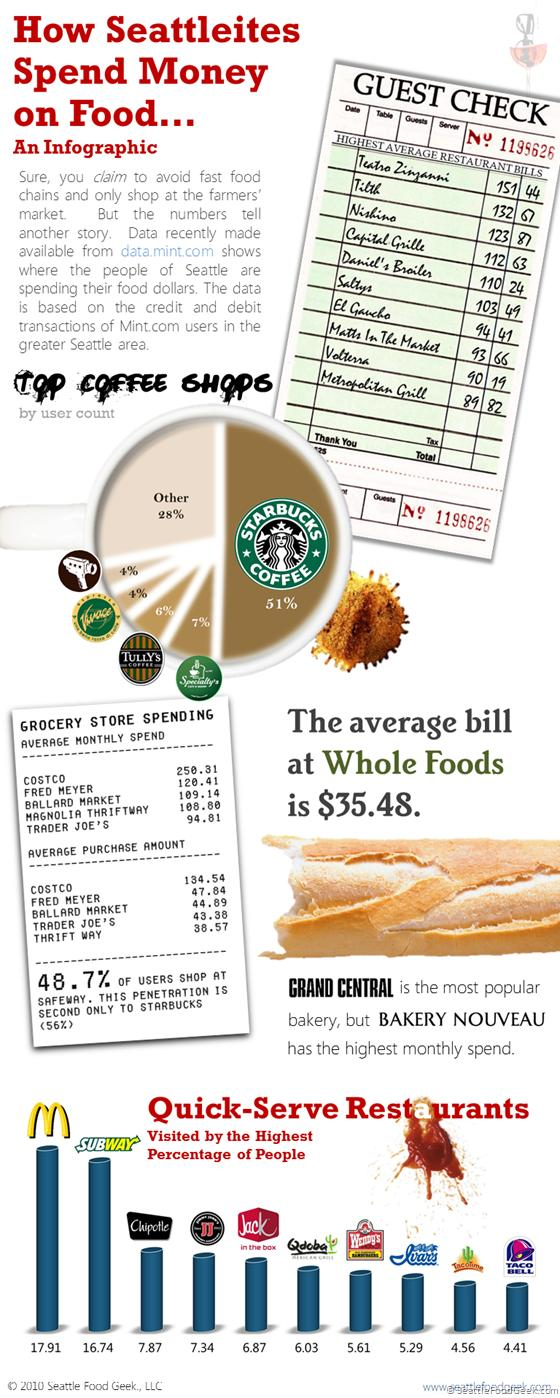Outline some significant characteristics in this image. Based on our data, Qdoba has 6.03% of visitors among all quick serve restaurants. According to the data, Taco Bell was the fast-food restaurant that ranked last among the quick-serve restaurants. According to a recent survey, 48.7% of people are shopping at Safeway. A significant percentage of customers visit Tully's for coffee. The average monthly spend at Costco is higher than at Fred Meyer by 129.9. 